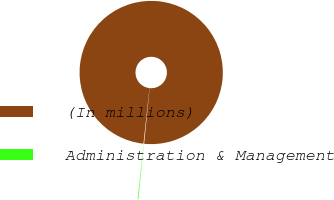Convert chart to OTSL. <chart><loc_0><loc_0><loc_500><loc_500><pie_chart><fcel>(In millions)<fcel>Administration & Management<nl><fcel>99.85%<fcel>0.15%<nl></chart> 